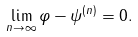Convert formula to latex. <formula><loc_0><loc_0><loc_500><loc_500>\lim _ { n \rightarrow \infty } \| \varphi - \psi ^ { ( n ) } \| = 0 .</formula> 